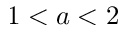<formula> <loc_0><loc_0><loc_500><loc_500>1 < a < 2</formula> 